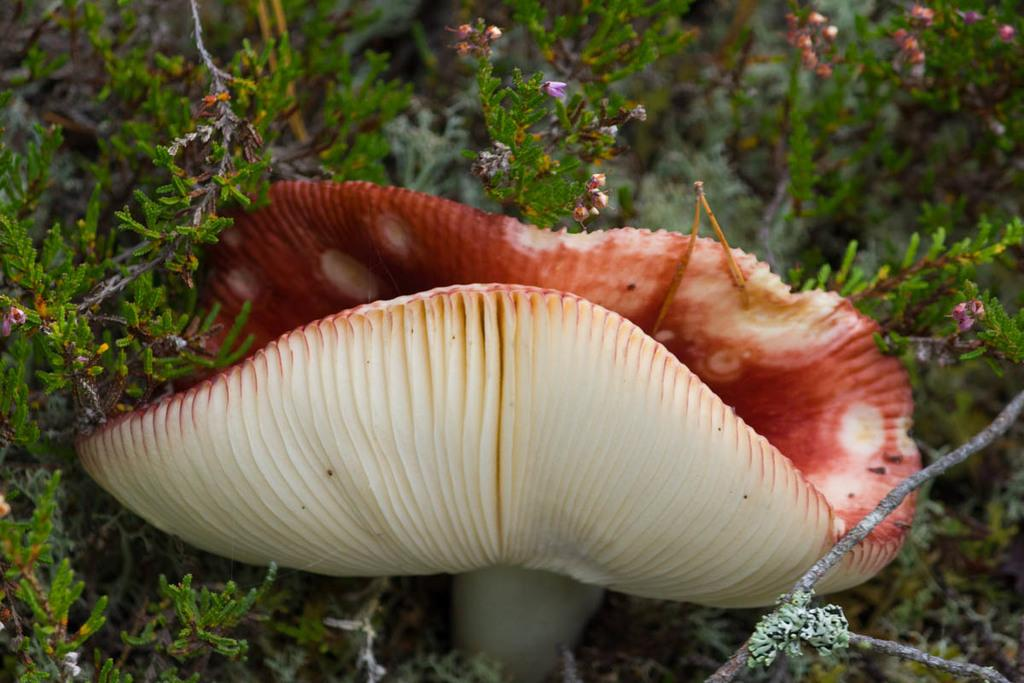What type of living organisms can be seen in the image? Plants can be seen in the image. Are there any fungi present in the image? Yes, there is a mushroom in the image. Can you see a shoe floating down the river in the image? There is no shoe or river present in the image; it only features plants and a mushroom. 